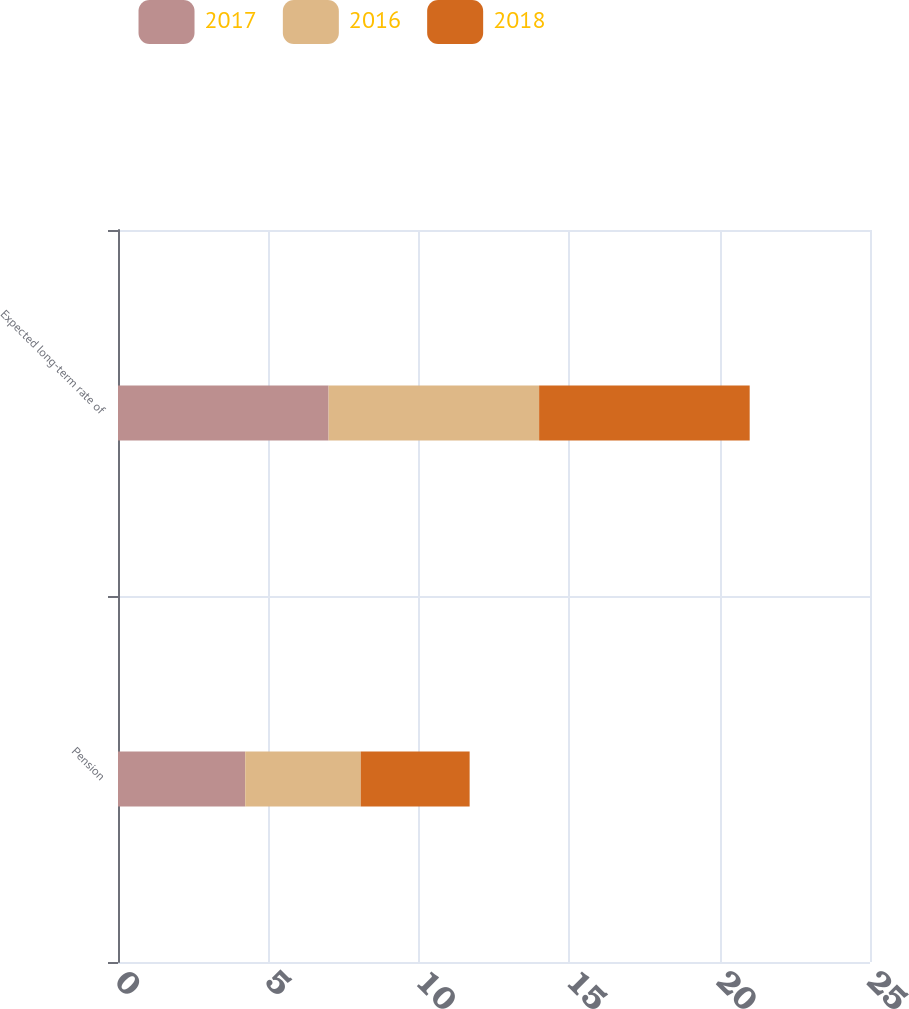<chart> <loc_0><loc_0><loc_500><loc_500><stacked_bar_chart><ecel><fcel>Pension<fcel>Expected long-term rate of<nl><fcel>2017<fcel>4.23<fcel>7<nl><fcel>2016<fcel>3.84<fcel>7<nl><fcel>2018<fcel>3.62<fcel>7<nl></chart> 